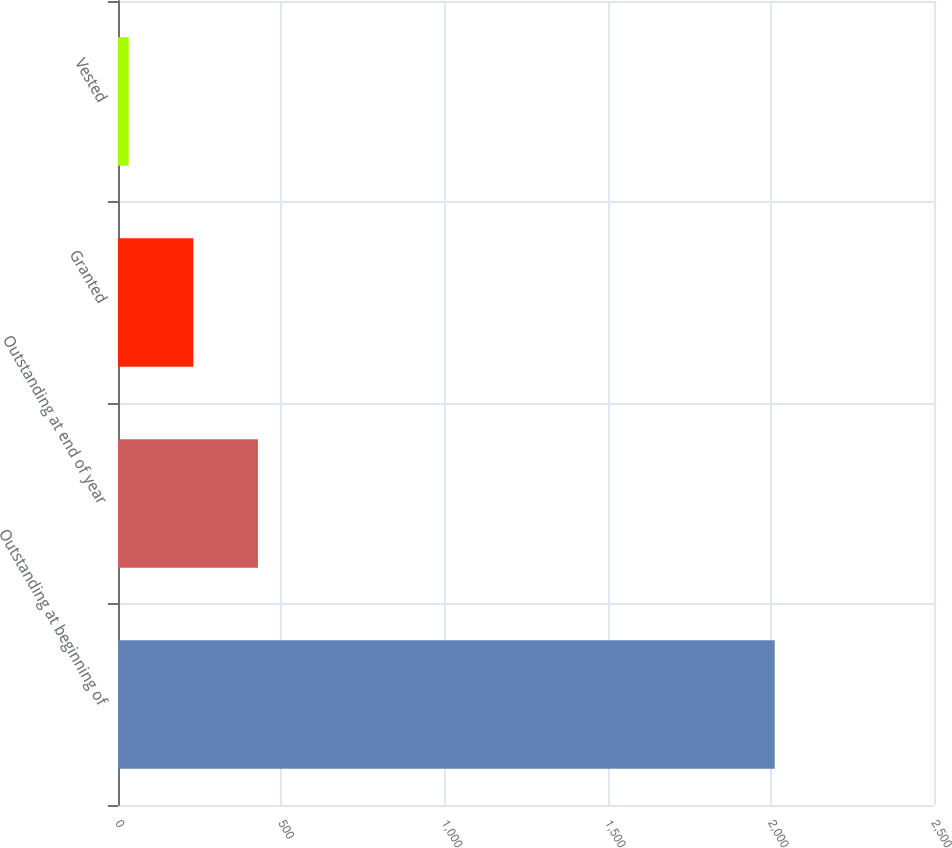Convert chart to OTSL. <chart><loc_0><loc_0><loc_500><loc_500><bar_chart><fcel>Outstanding at beginning of<fcel>Outstanding at end of year<fcel>Granted<fcel>Vested<nl><fcel>2012<fcel>428.72<fcel>230.81<fcel>32.9<nl></chart> 